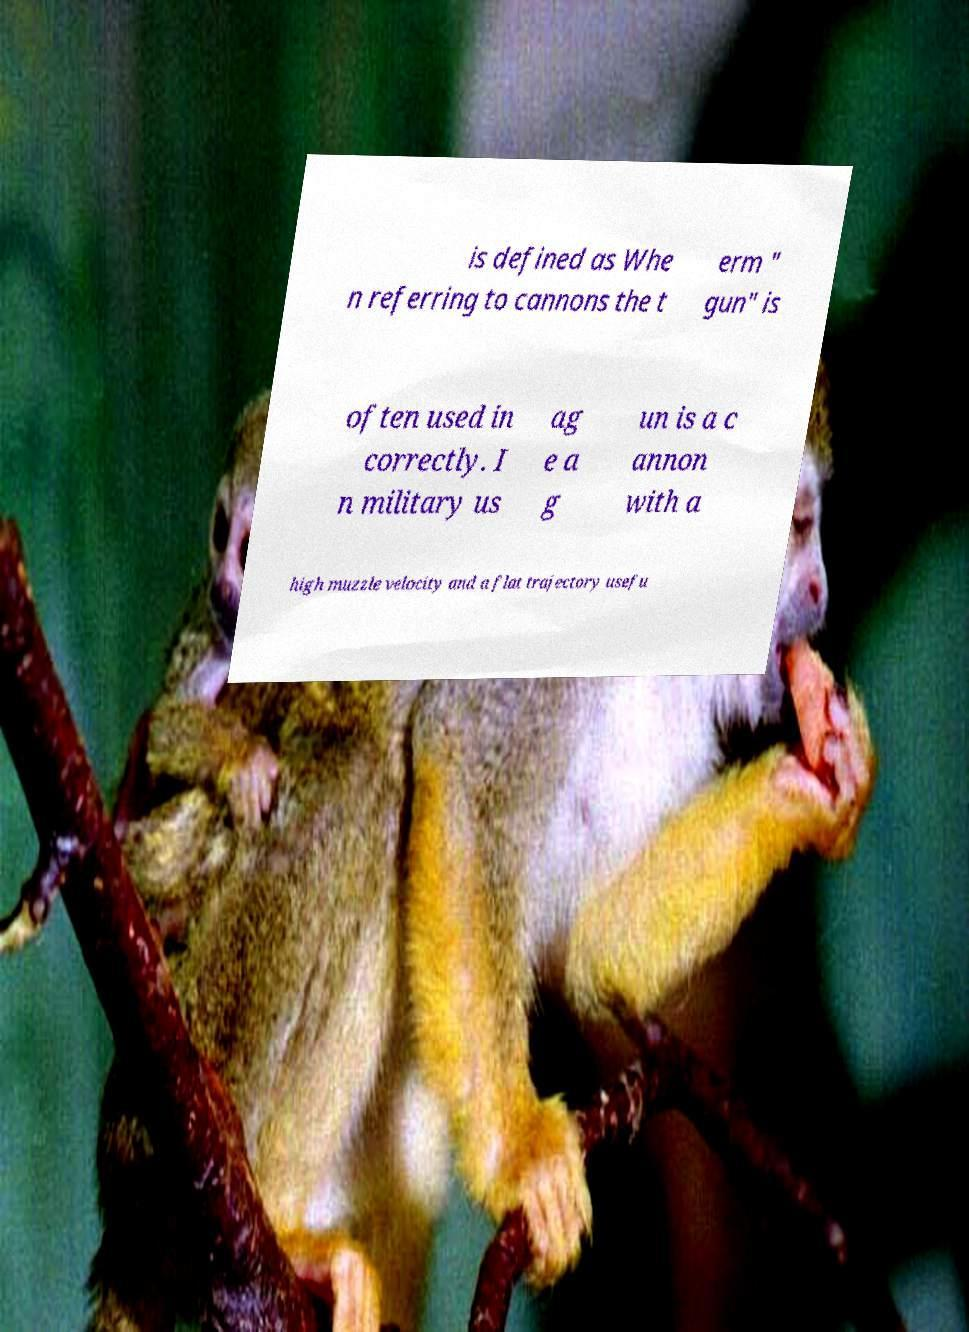What messages or text are displayed in this image? I need them in a readable, typed format. is defined as Whe n referring to cannons the t erm " gun" is often used in correctly. I n military us ag e a g un is a c annon with a high muzzle velocity and a flat trajectory usefu 